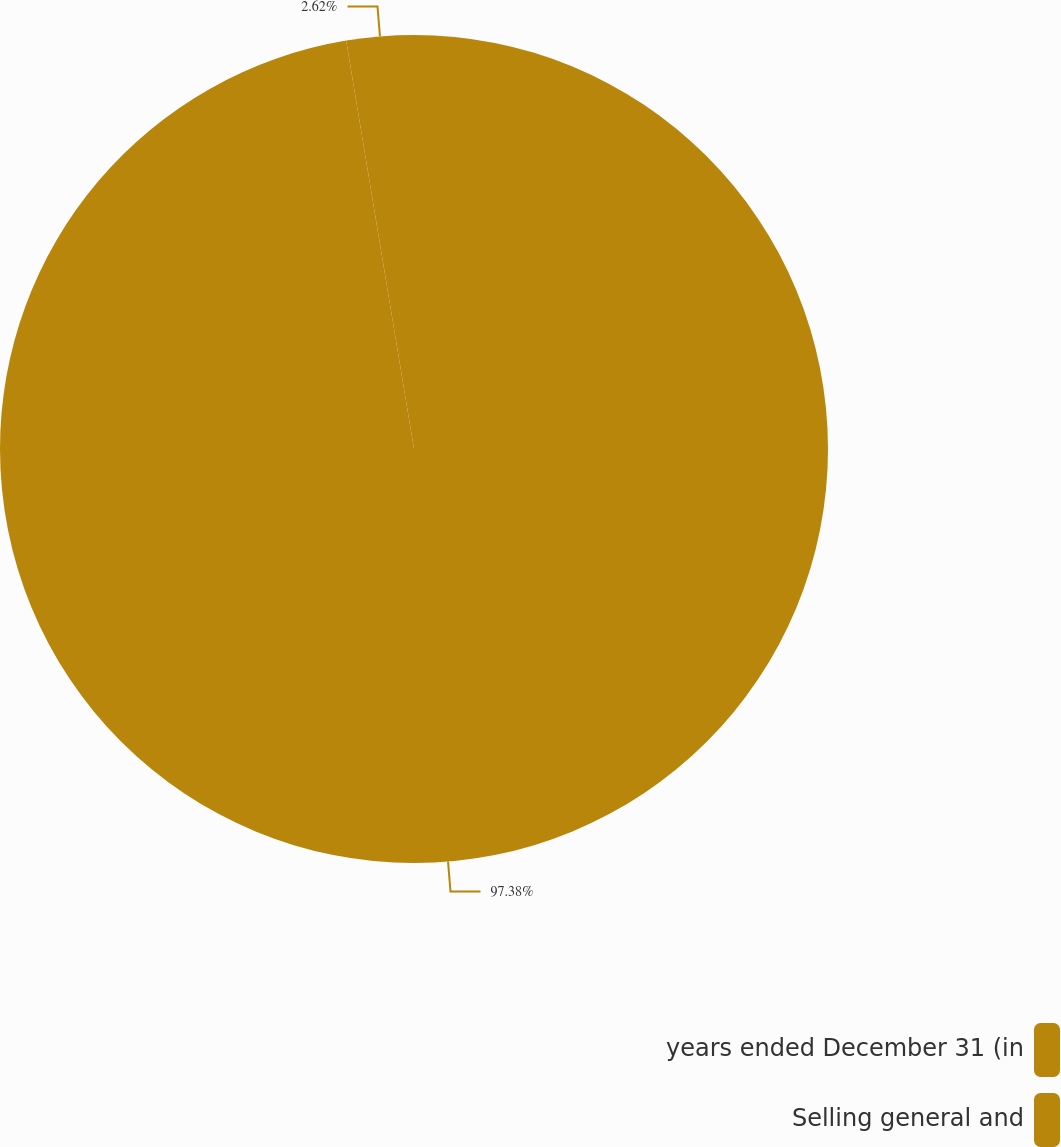Convert chart. <chart><loc_0><loc_0><loc_500><loc_500><pie_chart><fcel>years ended December 31 (in<fcel>Selling general and<nl><fcel>97.38%<fcel>2.62%<nl></chart> 